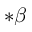<formula> <loc_0><loc_0><loc_500><loc_500>* \beta</formula> 